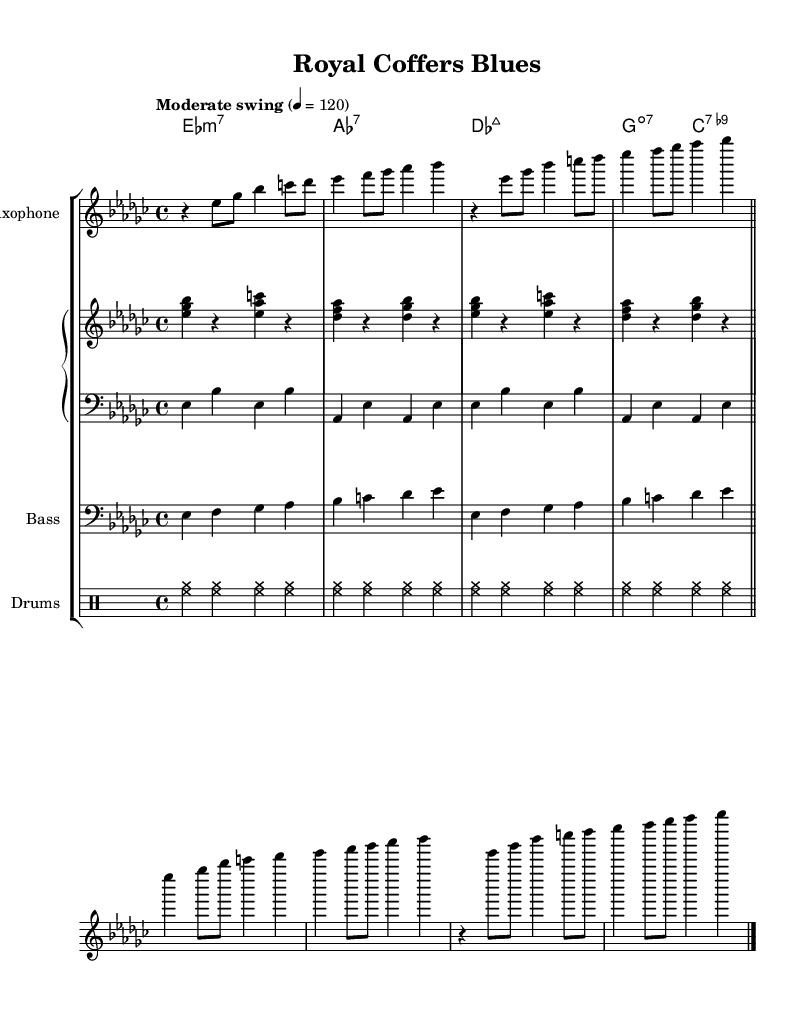What is the key signature of this music? The key signature is E flat minor, which has six sharps (D#, E#, G#, A#, B#, C#). This can be confirmed by identifying the flat symbols at the beginning of the staff.
Answer: E flat minor What is the time signature of this piece? The time signature is 4/4, indicated directly at the beginning of the staff before the notes. This means there are four beats in each measure and a quarter note receives one beat.
Answer: 4/4 What is the tempo marking of the piece? The tempo marking indicates a "Moderate swing" at a speed of 120 beats per minute, which denotes the style and speed of the performance. The marking is clear and placed at the beginning of the score.
Answer: Moderate swing How many measures are in the saxophone part? The saxophone part contains eight measures. Each measure is separated by vertical lines, and counting them reveals the total number.
Answer: Eight What type of chord is the first chord in the piano part? The first chord is an E flat minor seventh chord (E♭m7), derived from the chord symbols written above the staff. This shape is indicated in the chord symbols written above the piano staff.
Answer: E flat minor seventh What is the rhythmic pattern of the drums in this piece? The rhythmic pattern in the drums is a basic swing pattern, which is indicated by repeating the same hi-hat and cymbal strokes outlined in the drum notation. This provides a steady swing feel integral to jazz.
Answer: Swing pattern What genre does this piece belong to? The piece belongs to the Jazz genre, which can be inferred from the improvisational style and the swing rhythm that is characteristic of jazz music. Additionally, the instrumentation and chord choices reflect jazz traditions.
Answer: Jazz 